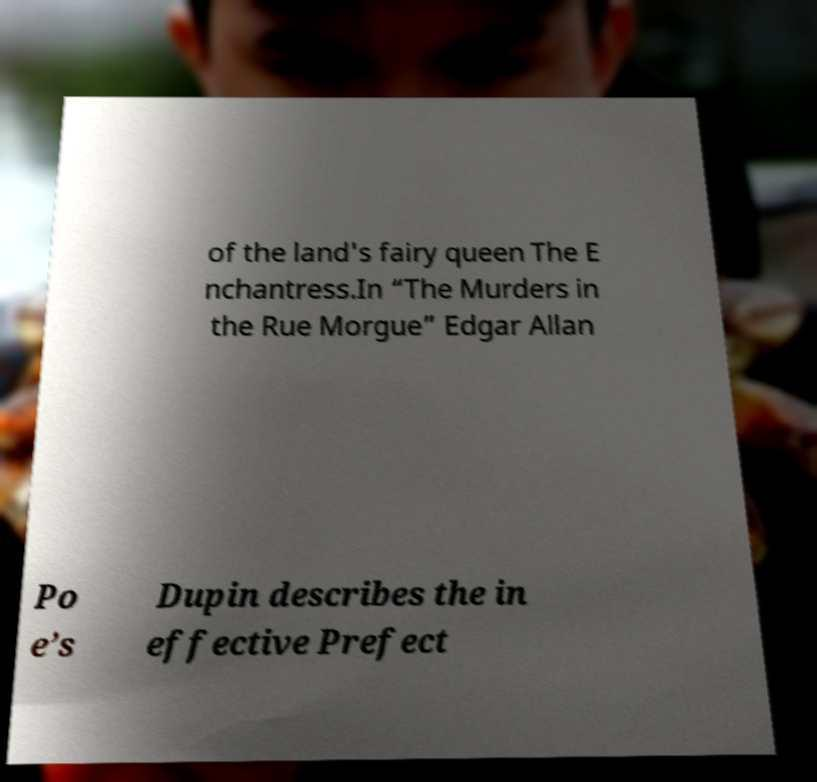Could you assist in decoding the text presented in this image and type it out clearly? of the land's fairy queen The E nchantress.In “The Murders in the Rue Morgue” Edgar Allan Po e’s Dupin describes the in effective Prefect 